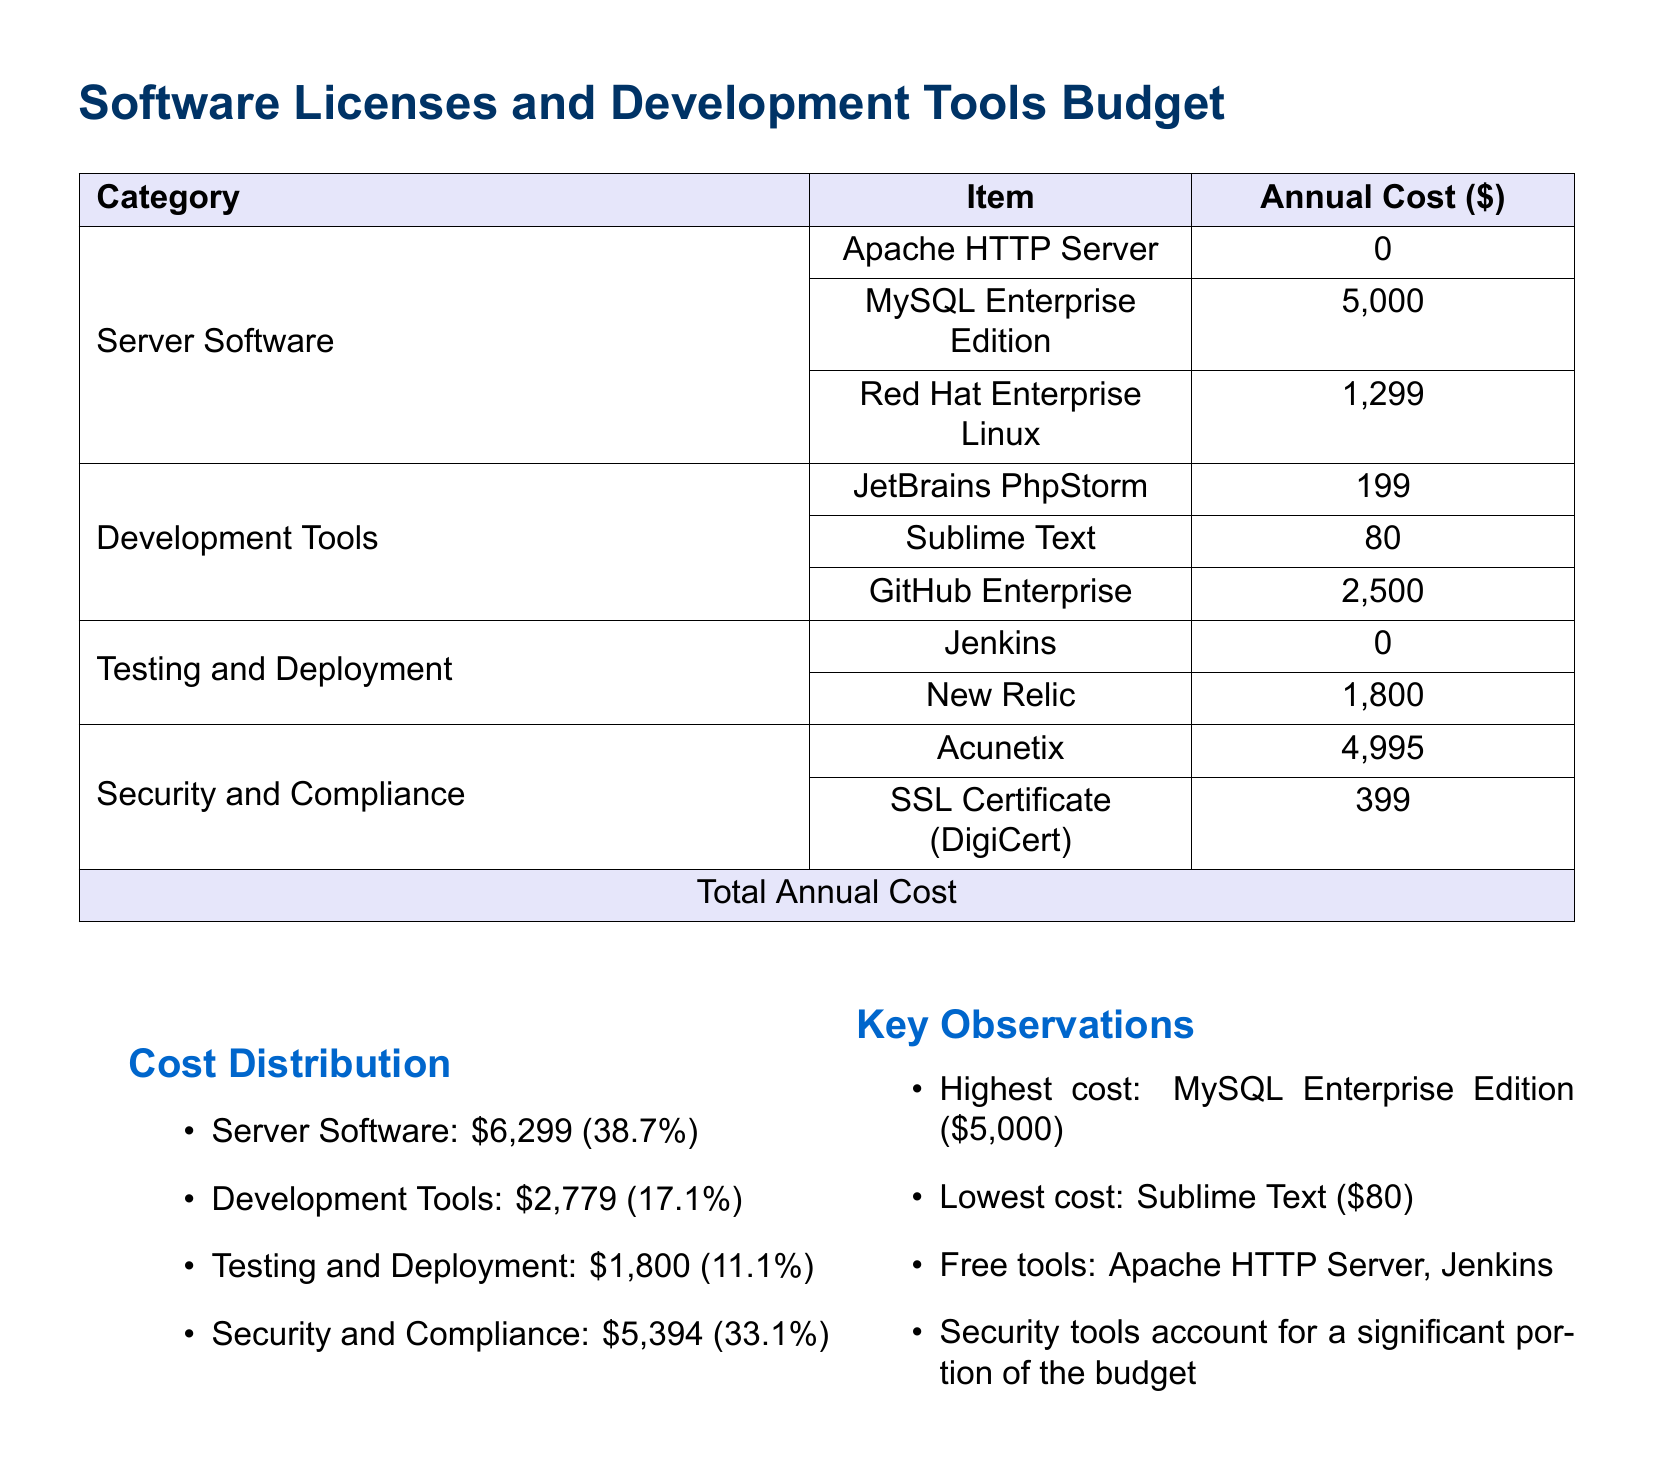What is the total annual cost? The total annual cost is provided as the sum of all expenses in the budget section at the end of the table.
Answer: 16,272 Which development tool has the lowest cost? The document lists all development tools with their associated costs, highlighting the lowest one.
Answer: Sublime Text What percentage of the budget is allocated to server software? The document includes a breakdown of cost distribution by category, specifying the percentage allotted to server software.
Answer: 38.7% What is the annual cost of MySQL Enterprise Edition? The document specifies the individual cost for MySQL Enterprise Edition under the server software category.
Answer: 5,000 Which category has the highest annual cost? The document summarizes cost distribution by category and indicates which one incurs the highest expenses.
Answer: Server Software How much does the SSL Certificate cost? The document lists the specific cost of the SSL Certificate under security and compliance.
Answer: 399 What is the cost of New Relic? The document provides details about the annual cost of New Relic within the testing and deployment section.
Answer: 1,800 Are there any free tools listed in the budget? The document specifically mentions the tools categorized as free within the server software and testing sections.
Answer: Yes Which tool is considered for security purposes? The document categorizes Acunetix as a security tool and provides its cost in the budget.
Answer: Acunetix 